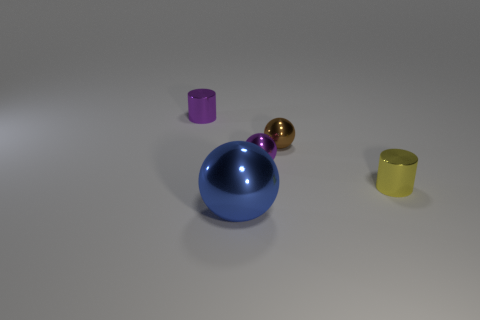What number of tiny objects are blue metal spheres or purple cylinders?
Provide a short and direct response. 1. What number of cylinders are there?
Provide a short and direct response. 2. What is the material of the cylinder right of the big blue ball?
Provide a short and direct response. Metal. There is a large blue thing; are there any blue shiny spheres in front of it?
Make the answer very short. No. Do the brown thing and the blue metal object have the same size?
Offer a terse response. No. How many large things are made of the same material as the big blue sphere?
Keep it short and to the point. 0. What size is the thing to the left of the sphere in front of the yellow cylinder?
Your answer should be compact. Small. What color is the metallic object that is both behind the yellow shiny cylinder and in front of the brown object?
Offer a terse response. Purple. Does the brown object have the same shape as the yellow shiny object?
Give a very brief answer. No. What shape is the purple thing right of the shiny object left of the large blue sphere?
Your answer should be very brief. Sphere. 